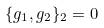Convert formula to latex. <formula><loc_0><loc_0><loc_500><loc_500>\{ g _ { 1 } , g _ { 2 } \} _ { 2 } = 0</formula> 